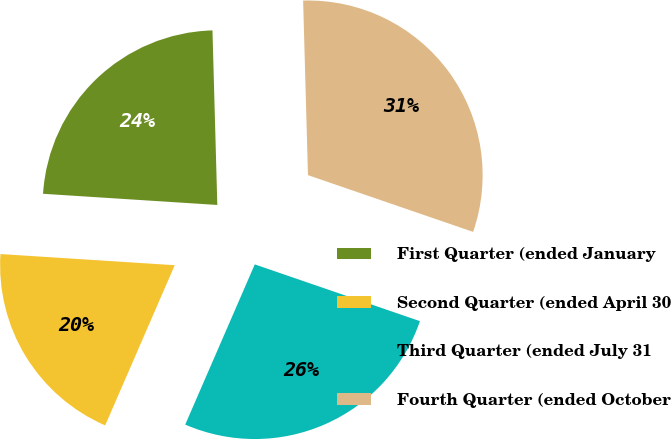Convert chart to OTSL. <chart><loc_0><loc_0><loc_500><loc_500><pie_chart><fcel>First Quarter (ended January<fcel>Second Quarter (ended April 30<fcel>Third Quarter (ended July 31<fcel>Fourth Quarter (ended October<nl><fcel>23.54%<fcel>19.5%<fcel>26.25%<fcel>30.71%<nl></chart> 